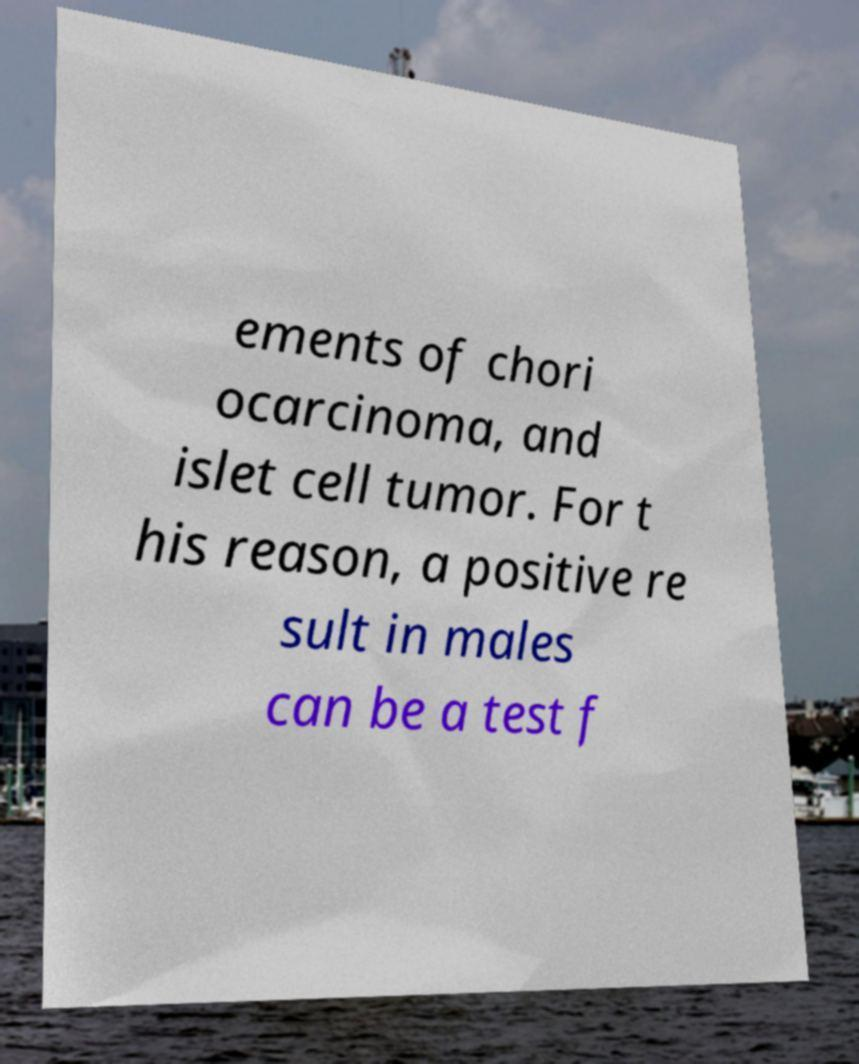Can you accurately transcribe the text from the provided image for me? ements of chori ocarcinoma, and islet cell tumor. For t his reason, a positive re sult in males can be a test f 